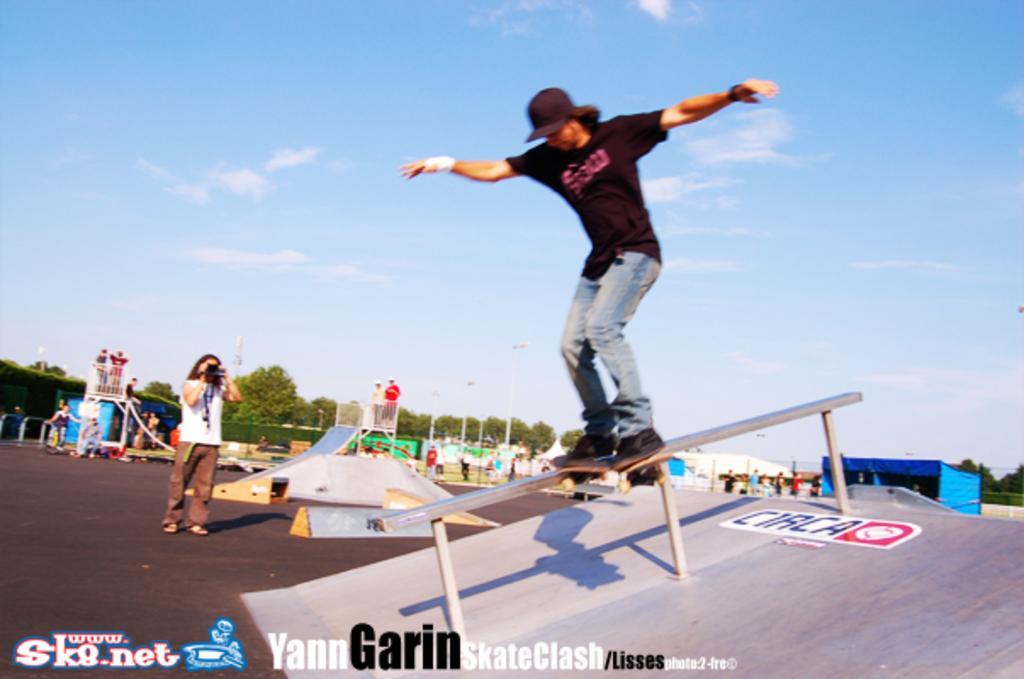Could you give a brief overview of what you see in this image? In the image there is a man in black t-shirt and jeans skating on a fence with a skateboard, on the left side there is a person taking pictures in camera, in the back there is playground with trees in the background and above its sky with clouds. 